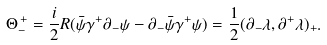Convert formula to latex. <formula><loc_0><loc_0><loc_500><loc_500>{ \Theta } _ { - } ^ { \, + } = \frac { i } { 2 } R ( \bar { \psi } { \gamma } ^ { + } { \partial } _ { - } { \psi } - { \partial } _ { - } \bar { \psi } { \gamma } ^ { + } { \psi } ) = \frac { 1 } { 2 } ( { \partial } _ { - } { \lambda } , { \partial } ^ { + } { \lambda } ) _ { + } .</formula> 